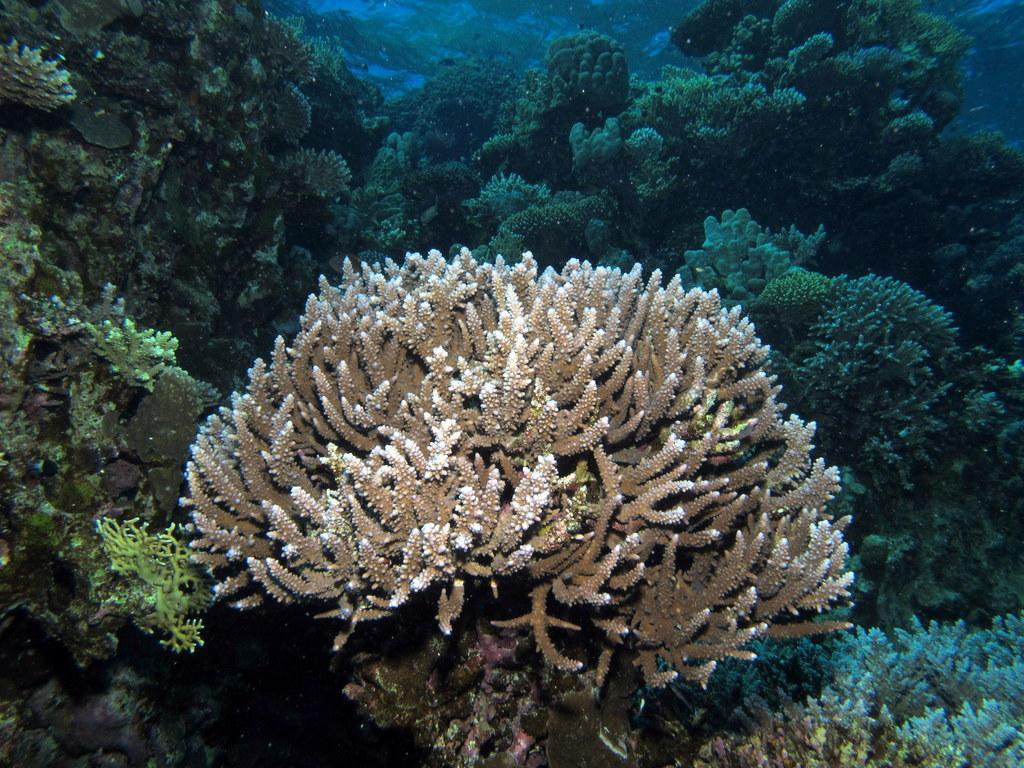What is the main subject of the image? The main subject of the image is the underwater beauty of the sea. Can you describe any specific features or objects in the image? Yes, there are bushes visible in the sea. What type of bells can be heard ringing underwater in the image? There are no bells present in the image, and therefore no such sound can be heard. 